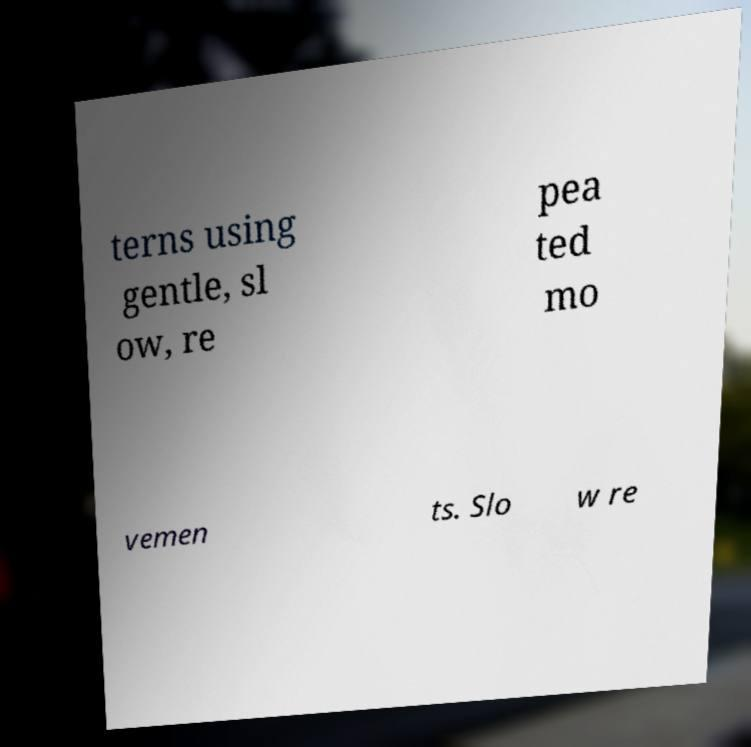For documentation purposes, I need the text within this image transcribed. Could you provide that? terns using gentle, sl ow, re pea ted mo vemen ts. Slo w re 